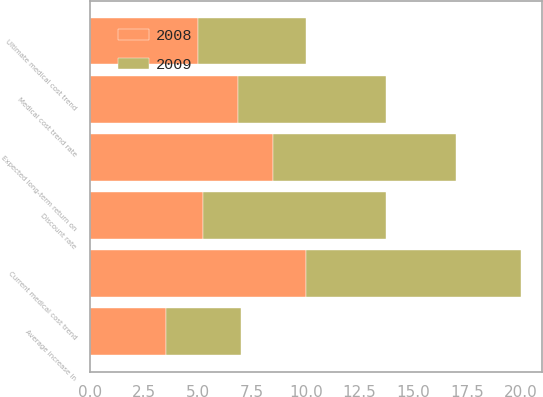Convert chart to OTSL. <chart><loc_0><loc_0><loc_500><loc_500><stacked_bar_chart><ecel><fcel>Discount rate<fcel>Average increase in<fcel>Expected long-term return on<fcel>Current medical cost trend<fcel>Ultimate medical cost trend<fcel>Medical cost trend rate<nl><fcel>2008<fcel>5.25<fcel>3.5<fcel>8.5<fcel>10<fcel>5<fcel>6.875<nl><fcel>2009<fcel>8.5<fcel>3.5<fcel>8.5<fcel>10<fcel>5<fcel>6.875<nl></chart> 